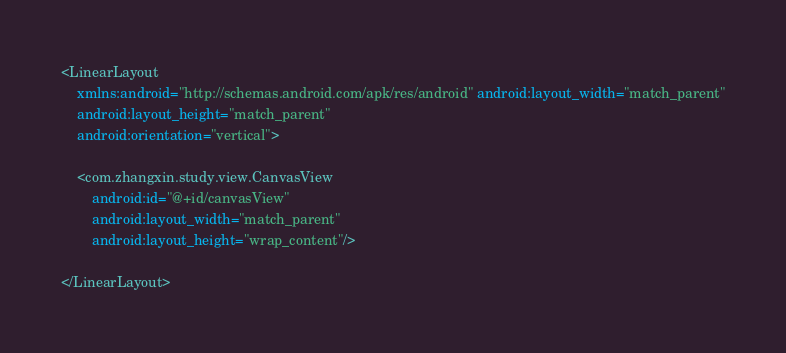Convert code to text. <code><loc_0><loc_0><loc_500><loc_500><_XML_><LinearLayout
    xmlns:android="http://schemas.android.com/apk/res/android" android:layout_width="match_parent"
    android:layout_height="match_parent"
    android:orientation="vertical">

    <com.zhangxin.study.view.CanvasView
        android:id="@+id/canvasView"
        android:layout_width="match_parent"
        android:layout_height="wrap_content"/>

</LinearLayout></code> 